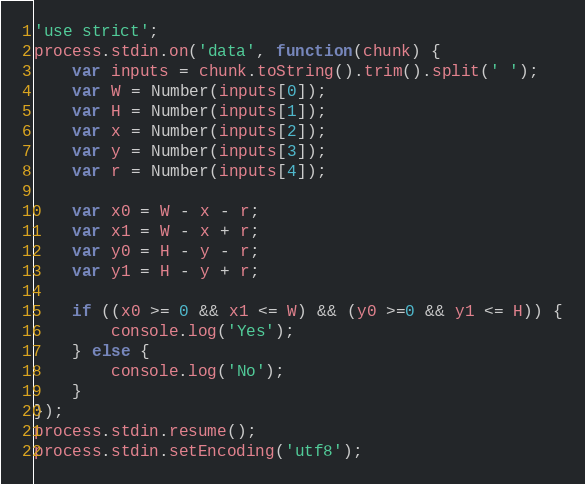Convert code to text. <code><loc_0><loc_0><loc_500><loc_500><_JavaScript_>'use strict';
process.stdin.on('data', function(chunk) {
    var inputs = chunk.toString().trim().split(' ');
    var W = Number(inputs[0]);
    var H = Number(inputs[1]);
    var x = Number(inputs[2]);
    var y = Number(inputs[3]);
    var r = Number(inputs[4]);

    var x0 = W - x - r;
    var x1 = W - x + r;
    var y0 = H - y - r;
    var y1 = H - y + r;

    if ((x0 >= 0 && x1 <= W) && (y0 >=0 && y1 <= H)) {
        console.log('Yes');
    } else {
        console.log('No');
    }
});
process.stdin.resume();
process.stdin.setEncoding('utf8');</code> 